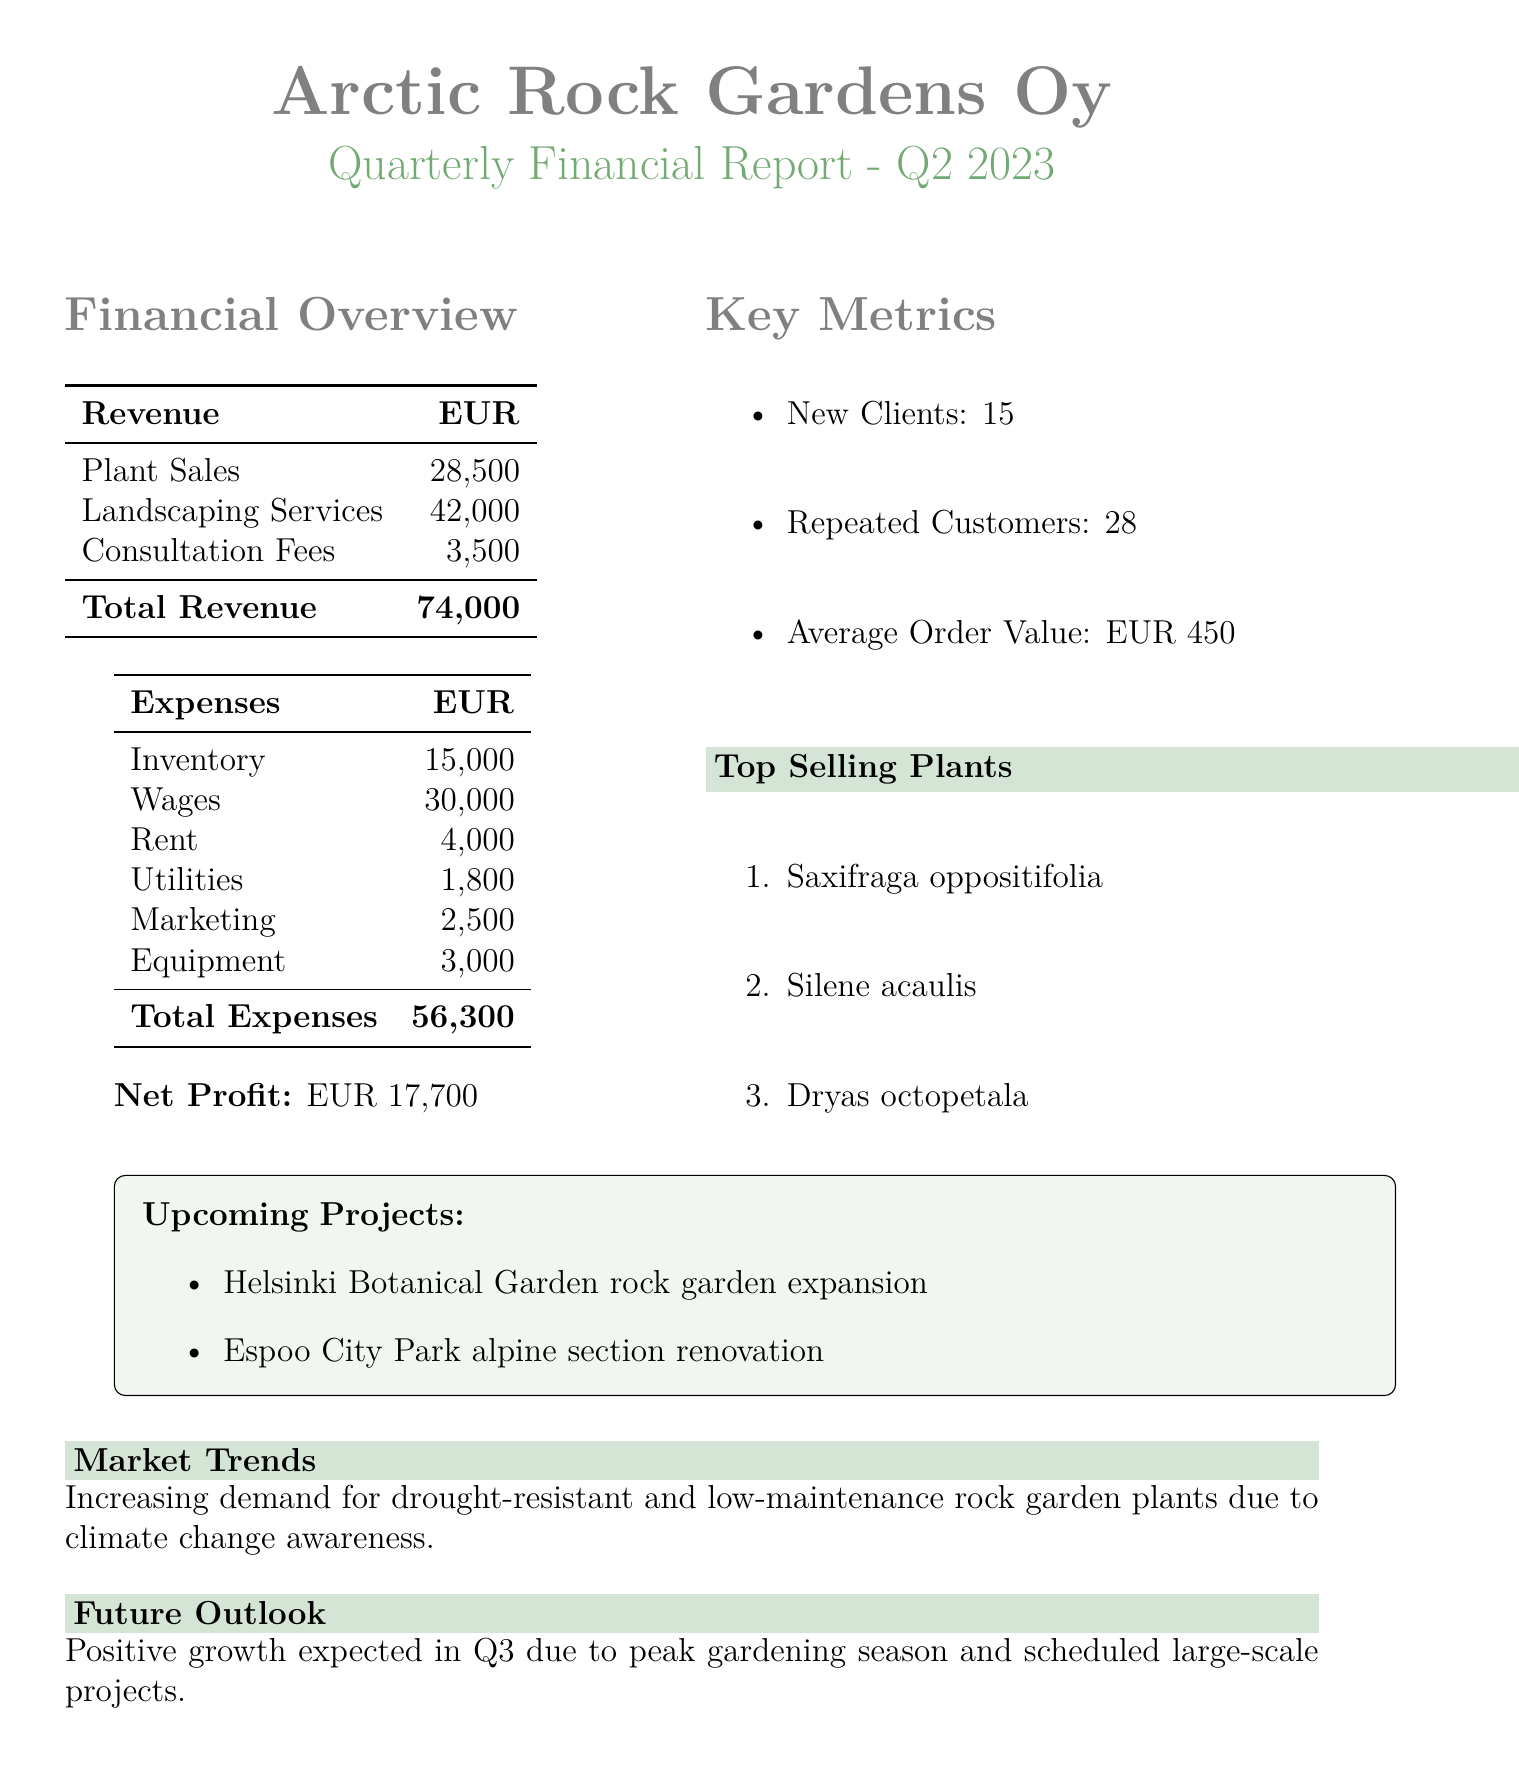What is the total revenue? The total revenue is the sum of all revenue sources in the document: 28500 + 42000 + 3500 = 74000.
Answer: 74000 What was the net profit for Q2 2023? The net profit is explicitly stated in the document as EUR 17700.
Answer: 17700 How many new clients did Arctic Rock Gardens Oy acquire? The document indicates that the company acquired 15 new clients during the quarter.
Answer: 15 What are the top-selling plants? The document lists Saxifraga oppositifolia, Silene acaulis, and Dryas octopetala as the top-selling plants, highlighting their popularity.
Answer: Saxifraga oppositifolia, Silene acaulis, Dryas octopetala What is the total amount spent on wages? The document specifies that the expenses for wages amount to EUR 30000.
Answer: 30000 What is the anticipated growth in Q3 based on the document? The future outlook section indicates that positive growth is expected due to the peak gardening season and scheduled projects.
Answer: Positive growth How many repeated customers were there? The document mentions that there were 28 repeated customers, signifying customer loyalty.
Answer: 28 What is the average order value stated in the report? The average order value is stated as EUR 450 in the key metrics section of the document.
Answer: 450 What upcoming project is mentioned in the report? The document lists the Helsinki Botanical Garden rock garden expansion and the Espoo City Park alpine section renovation as upcoming projects.
Answer: Helsinki Botanical Garden rock garden expansion, Espoo City Park alpine section renovation 